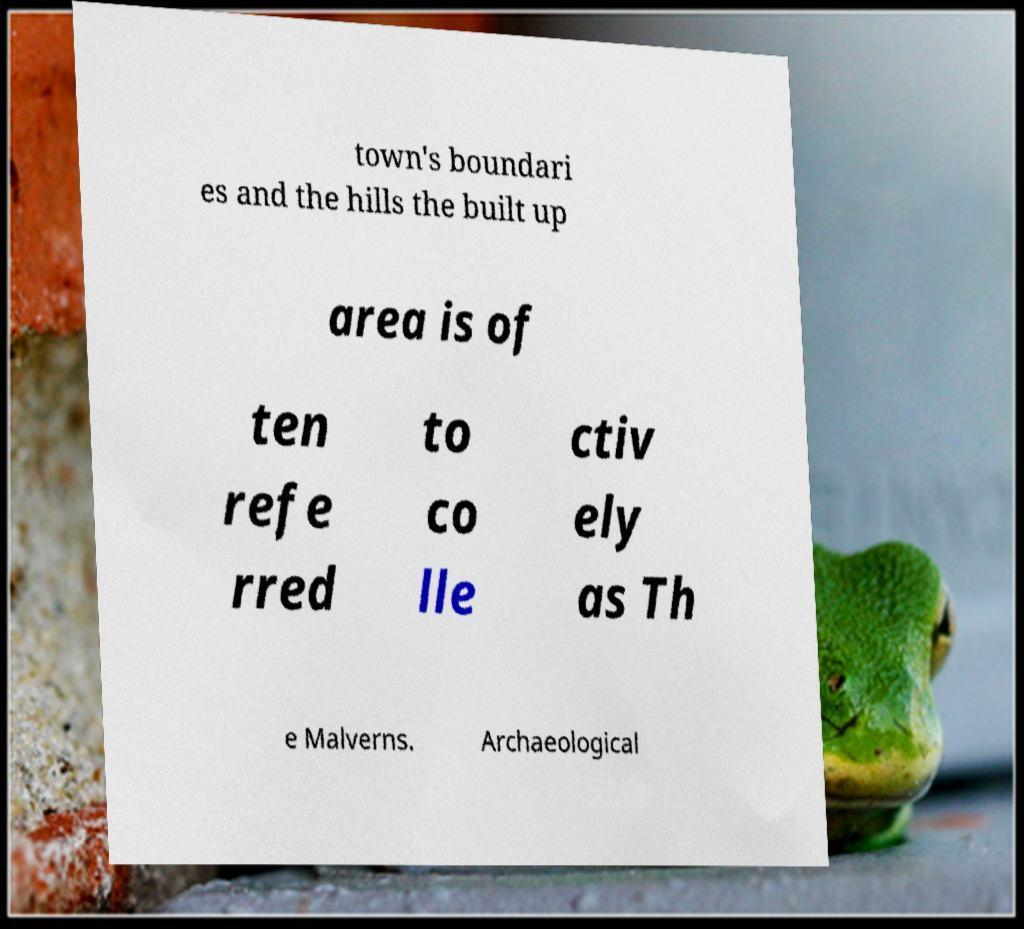Can you accurately transcribe the text from the provided image for me? town's boundari es and the hills the built up area is of ten refe rred to co lle ctiv ely as Th e Malverns. Archaeological 